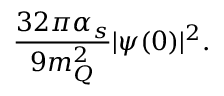Convert formula to latex. <formula><loc_0><loc_0><loc_500><loc_500>\frac { 3 2 \pi \alpha _ { s } } { 9 m _ { Q } ^ { 2 } } | \psi ( 0 ) | ^ { 2 } .</formula> 